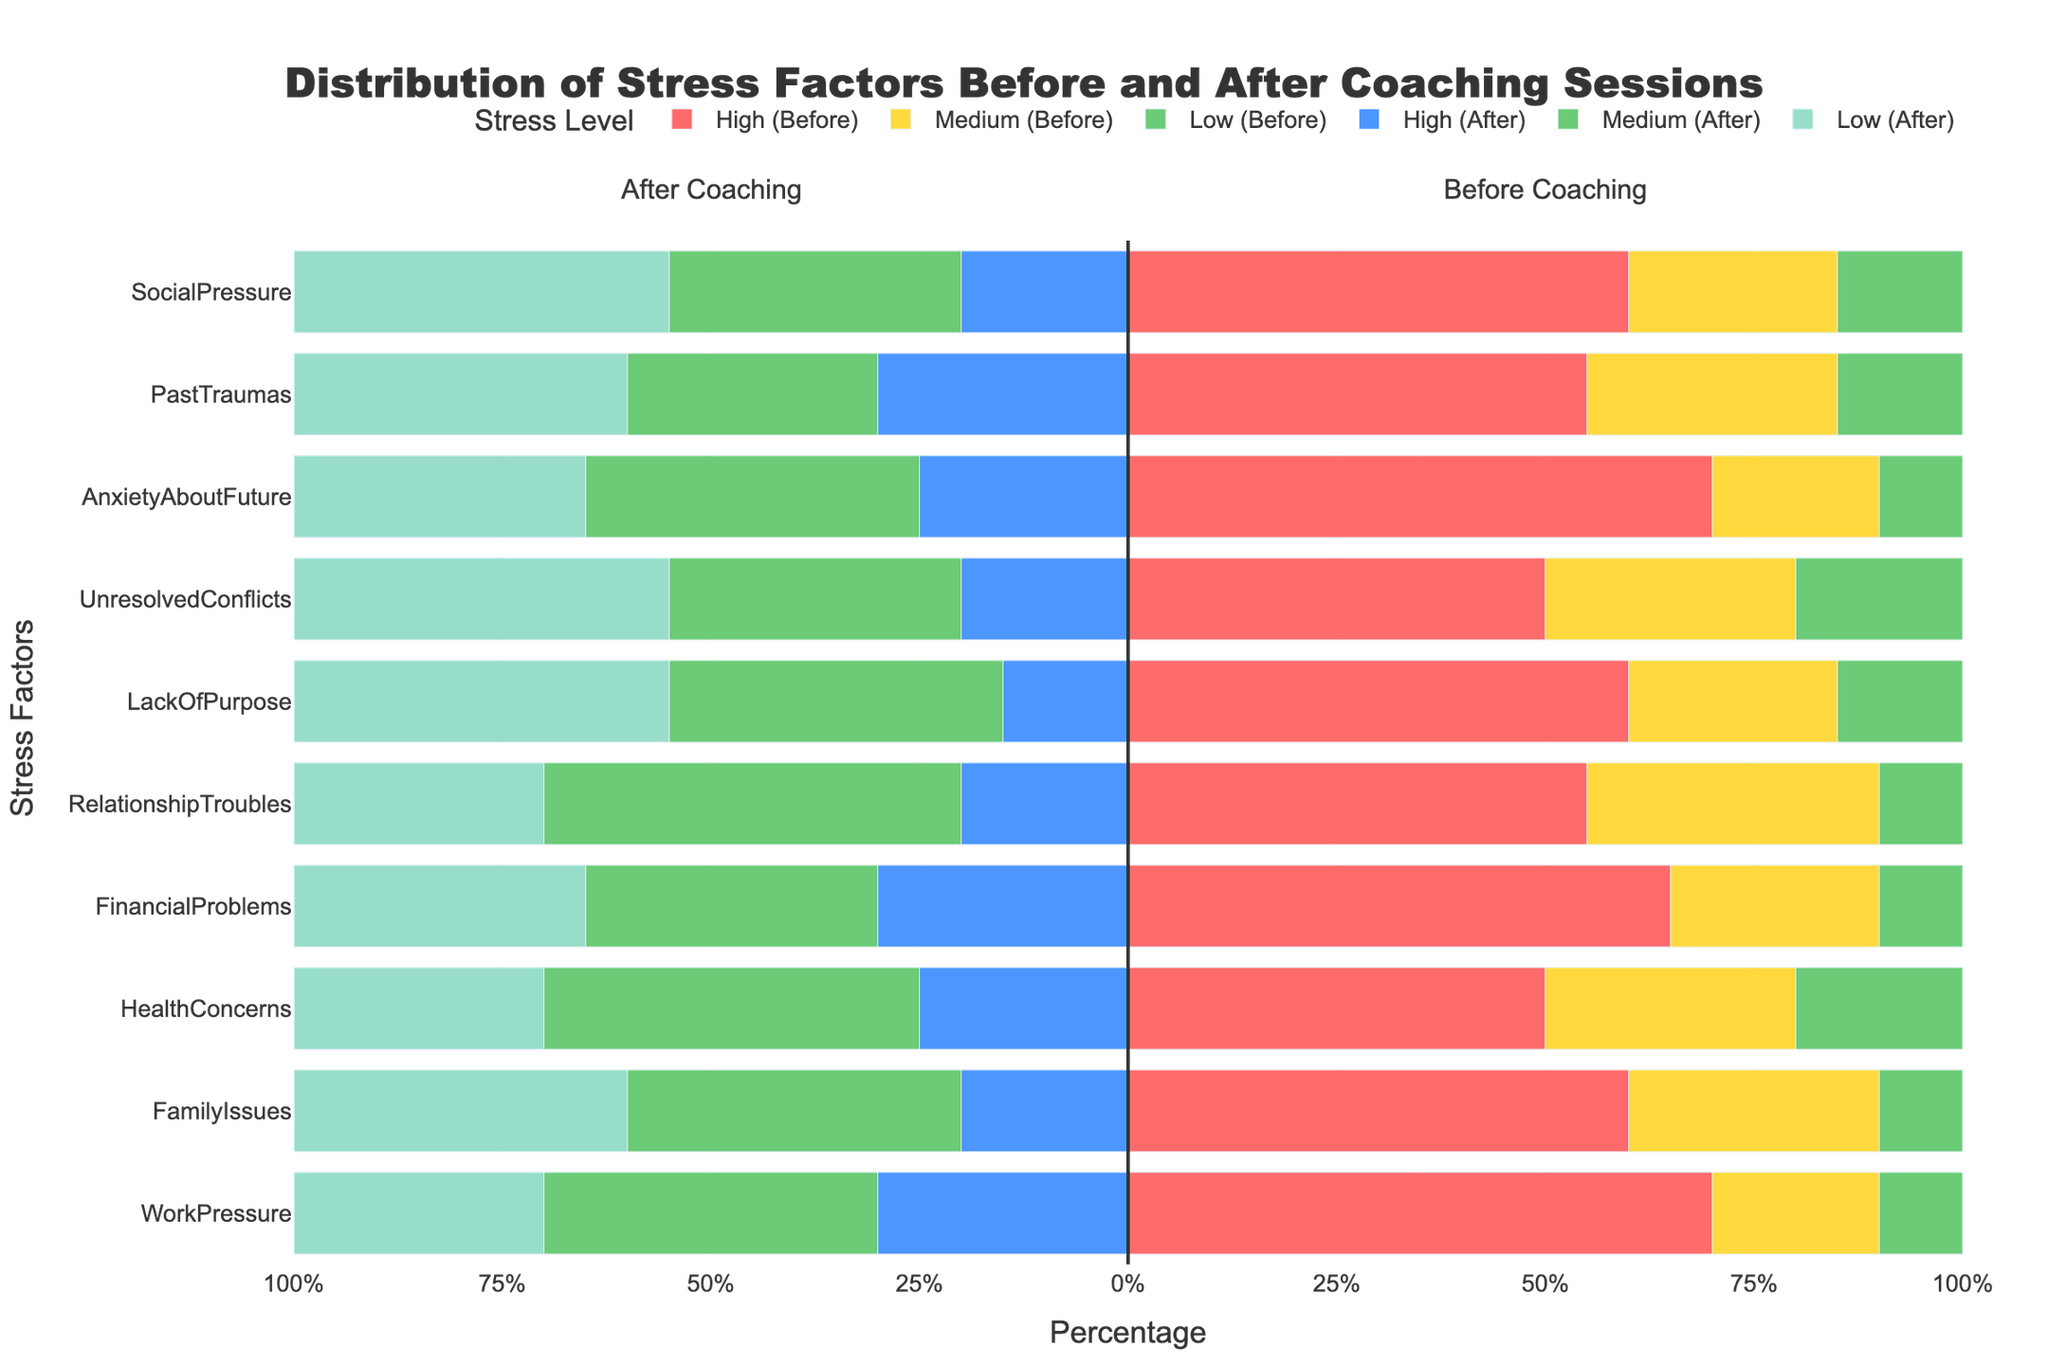Which stress factor had the highest percentage of "High" stress level before coaching? Look at the bars representing the "High (Before)" for each stress factor. Identify the stress factor with the longest "High (Before)" bar.
Answer: WorkPressure and AnxietyAboutFuture Which stress factor saw the greatest reduction in the "High" stress level after coaching sessions? Compare the "High (Before)" and "High (After)" bars for each stress factor. Find the stress factor with the largest difference between these two bars.
Answer: WorkPressure For HealthConcerns, what is the combined percentage of "Medium" and "Low" stress levels after coaching sessions? Identify the "Medium (After)" and "Low (After)" bars for HealthConcerns. Sum the lengths (in percentages) of these two bars. 45% (Medium) + 30% (Low) = 75%
Answer: 75% Which stress factor had the smallest change in the "High" stress level after coaching sessions? Compare the "High (Before)" and "High (After)" bars for each stress factor. Look for the smallest difference between these two bars.
Answer: HealthConcerns and PastTraumas Between FamilyIssues and FinancialProblems, which one had a higher percentage of "Low" stress level before coaching sessions? Compare the "Low (Before)" bars for FamilyIssues and FinancialProblems. Identify which one is longer.
Answer: FamilyIssues What is the range in percentages for the "Medium" stress level for LackOfPurpose before and after coaching sessions? Identify the "Medium" stress level before and after coaching for LackOfPurpose. Calculate the range (difference) between these two percentages. 40% (After) - 25% (Before) = 15%
Answer: 15% Which stress factor transitioned from being primarily "High" to "Medium" stress level after coaching sessions? Look for a stress factor where the "High (Before)" bar is the longest and transitions to having a longer "Medium (After)" bar after coaching.
Answer: WorkPressure Which three stress factors had a "Low" stress level percentage of 45% after coaching sessions? Identify the stress factors where the "Low (After)" bar is 45% and list them.
Answer: LackOfPurpose, UnresolvedConflicts, and SocialPressure For RelationshipTroubles, what is the approximate total percentage reduction in "High" and "Medium" stress levels after coaching sessions? Calculate the reduction in "High" and "Medium" stress levels for RelationshipTroubles by subtracting the "After Coaching" values from "Before Coaching". Sum the reductions. (55% - 20%) + (35% - 50%) = 35% + (-15%) = 20%
Answer: 20% Which stress factor had the highest percentage of "Low" stress level before coaching sessions and also showed an increase in the percentage of "Low" stress level after coaching sessions? Identify the highest "Low (Before)" percentage and then check if the corresponding "Low (After)" percentage is also higher.
Answer: HealthConcerns and PastTraumas 